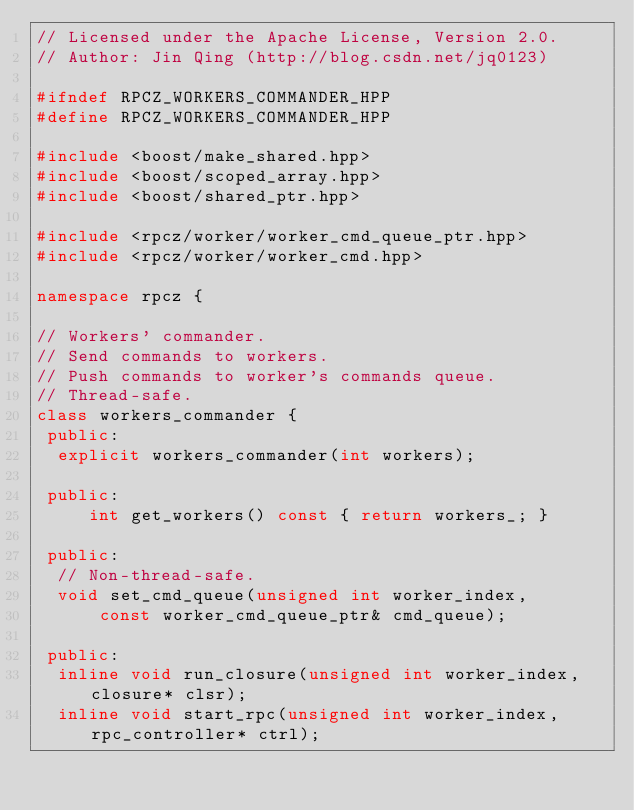<code> <loc_0><loc_0><loc_500><loc_500><_C++_>// Licensed under the Apache License, Version 2.0.
// Author: Jin Qing (http://blog.csdn.net/jq0123)

#ifndef RPCZ_WORKERS_COMMANDER_HPP
#define RPCZ_WORKERS_COMMANDER_HPP

#include <boost/make_shared.hpp>
#include <boost/scoped_array.hpp>
#include <boost/shared_ptr.hpp>

#include <rpcz/worker/worker_cmd_queue_ptr.hpp>
#include <rpcz/worker/worker_cmd.hpp>

namespace rpcz {

// Workers' commander.
// Send commands to workers.
// Push commands to worker's commands queue.
// Thread-safe.
class workers_commander {
 public:
  explicit workers_commander(int workers);

 public:
     int get_workers() const { return workers_; }

 public:
  // Non-thread-safe.
  void set_cmd_queue(unsigned int worker_index,
      const worker_cmd_queue_ptr& cmd_queue);

 public:
  inline void run_closure(unsigned int worker_index, closure* clsr);
  inline void start_rpc(unsigned int worker_index, rpc_controller* ctrl);</code> 